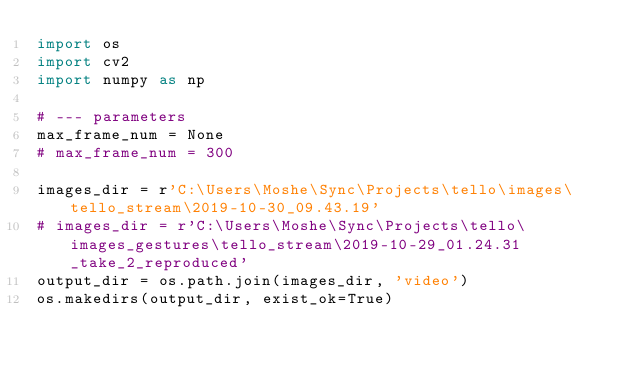<code> <loc_0><loc_0><loc_500><loc_500><_Python_>import os
import cv2
import numpy as np

# --- parameters
max_frame_num = None
# max_frame_num = 300

images_dir = r'C:\Users\Moshe\Sync\Projects\tello\images\tello_stream\2019-10-30_09.43.19'
# images_dir = r'C:\Users\Moshe\Sync\Projects\tello\images_gestures\tello_stream\2019-10-29_01.24.31_take_2_reproduced'
output_dir = os.path.join(images_dir, 'video')
os.makedirs(output_dir, exist_ok=True)</code> 